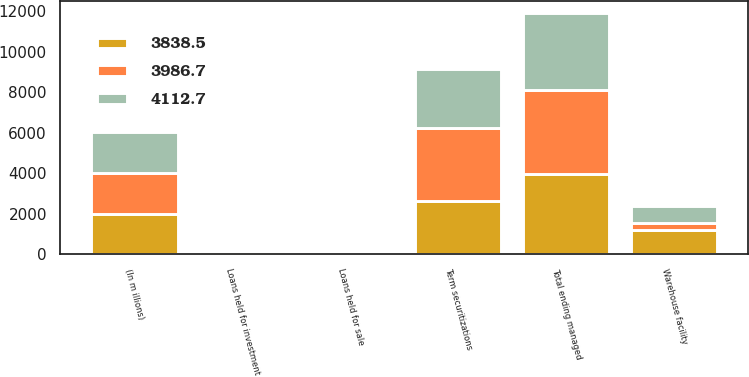Convert chart. <chart><loc_0><loc_0><loc_500><loc_500><stacked_bar_chart><ecel><fcel>(In m illions)<fcel>Warehouse facility<fcel>Term securitizations<fcel>Loans held for investment<fcel>Loans held for sale<fcel>Total ending managed<nl><fcel>3986.7<fcel>2010<fcel>331<fcel>3615.6<fcel>135.5<fcel>30.6<fcel>4112.7<nl><fcel>3838.5<fcel>2009<fcel>1215<fcel>2616.9<fcel>145.1<fcel>9.7<fcel>3986.7<nl><fcel>4112.7<fcel>2008<fcel>854.5<fcel>2910<fcel>69<fcel>5<fcel>3838.5<nl></chart> 